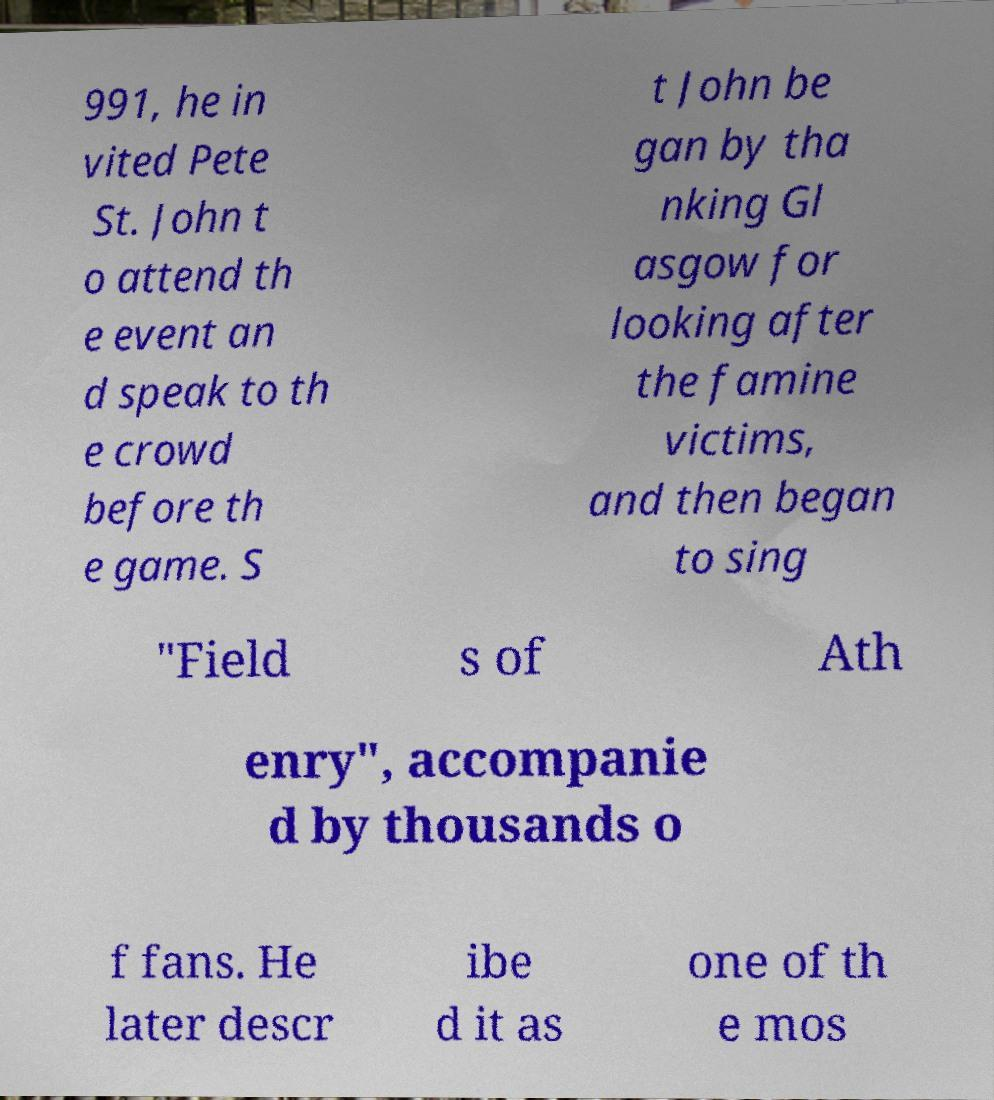Could you assist in decoding the text presented in this image and type it out clearly? 991, he in vited Pete St. John t o attend th e event an d speak to th e crowd before th e game. S t John be gan by tha nking Gl asgow for looking after the famine victims, and then began to sing "Field s of Ath enry", accompanie d by thousands o f fans. He later descr ibe d it as one of th e mos 